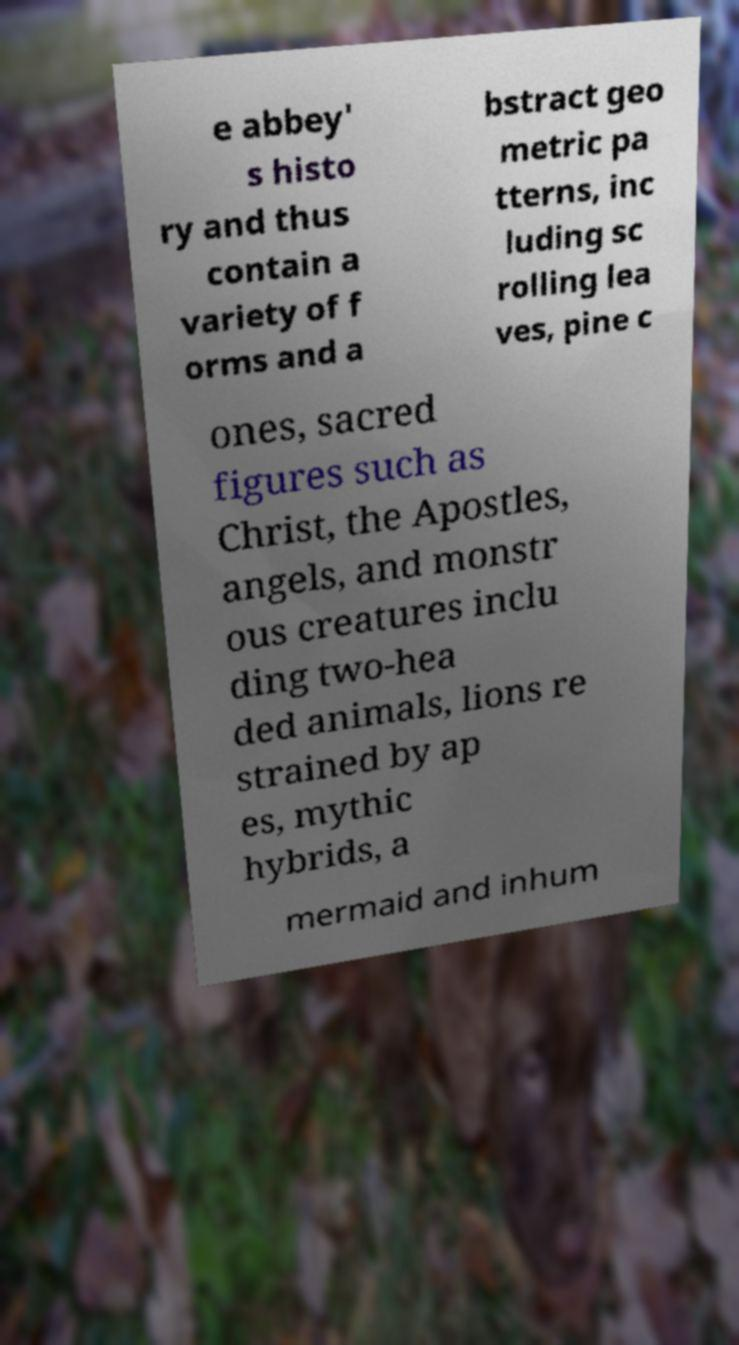Please read and relay the text visible in this image. What does it say? e abbey' s histo ry and thus contain a variety of f orms and a bstract geo metric pa tterns, inc luding sc rolling lea ves, pine c ones, sacred figures such as Christ, the Apostles, angels, and monstr ous creatures inclu ding two-hea ded animals, lions re strained by ap es, mythic hybrids, a mermaid and inhum 